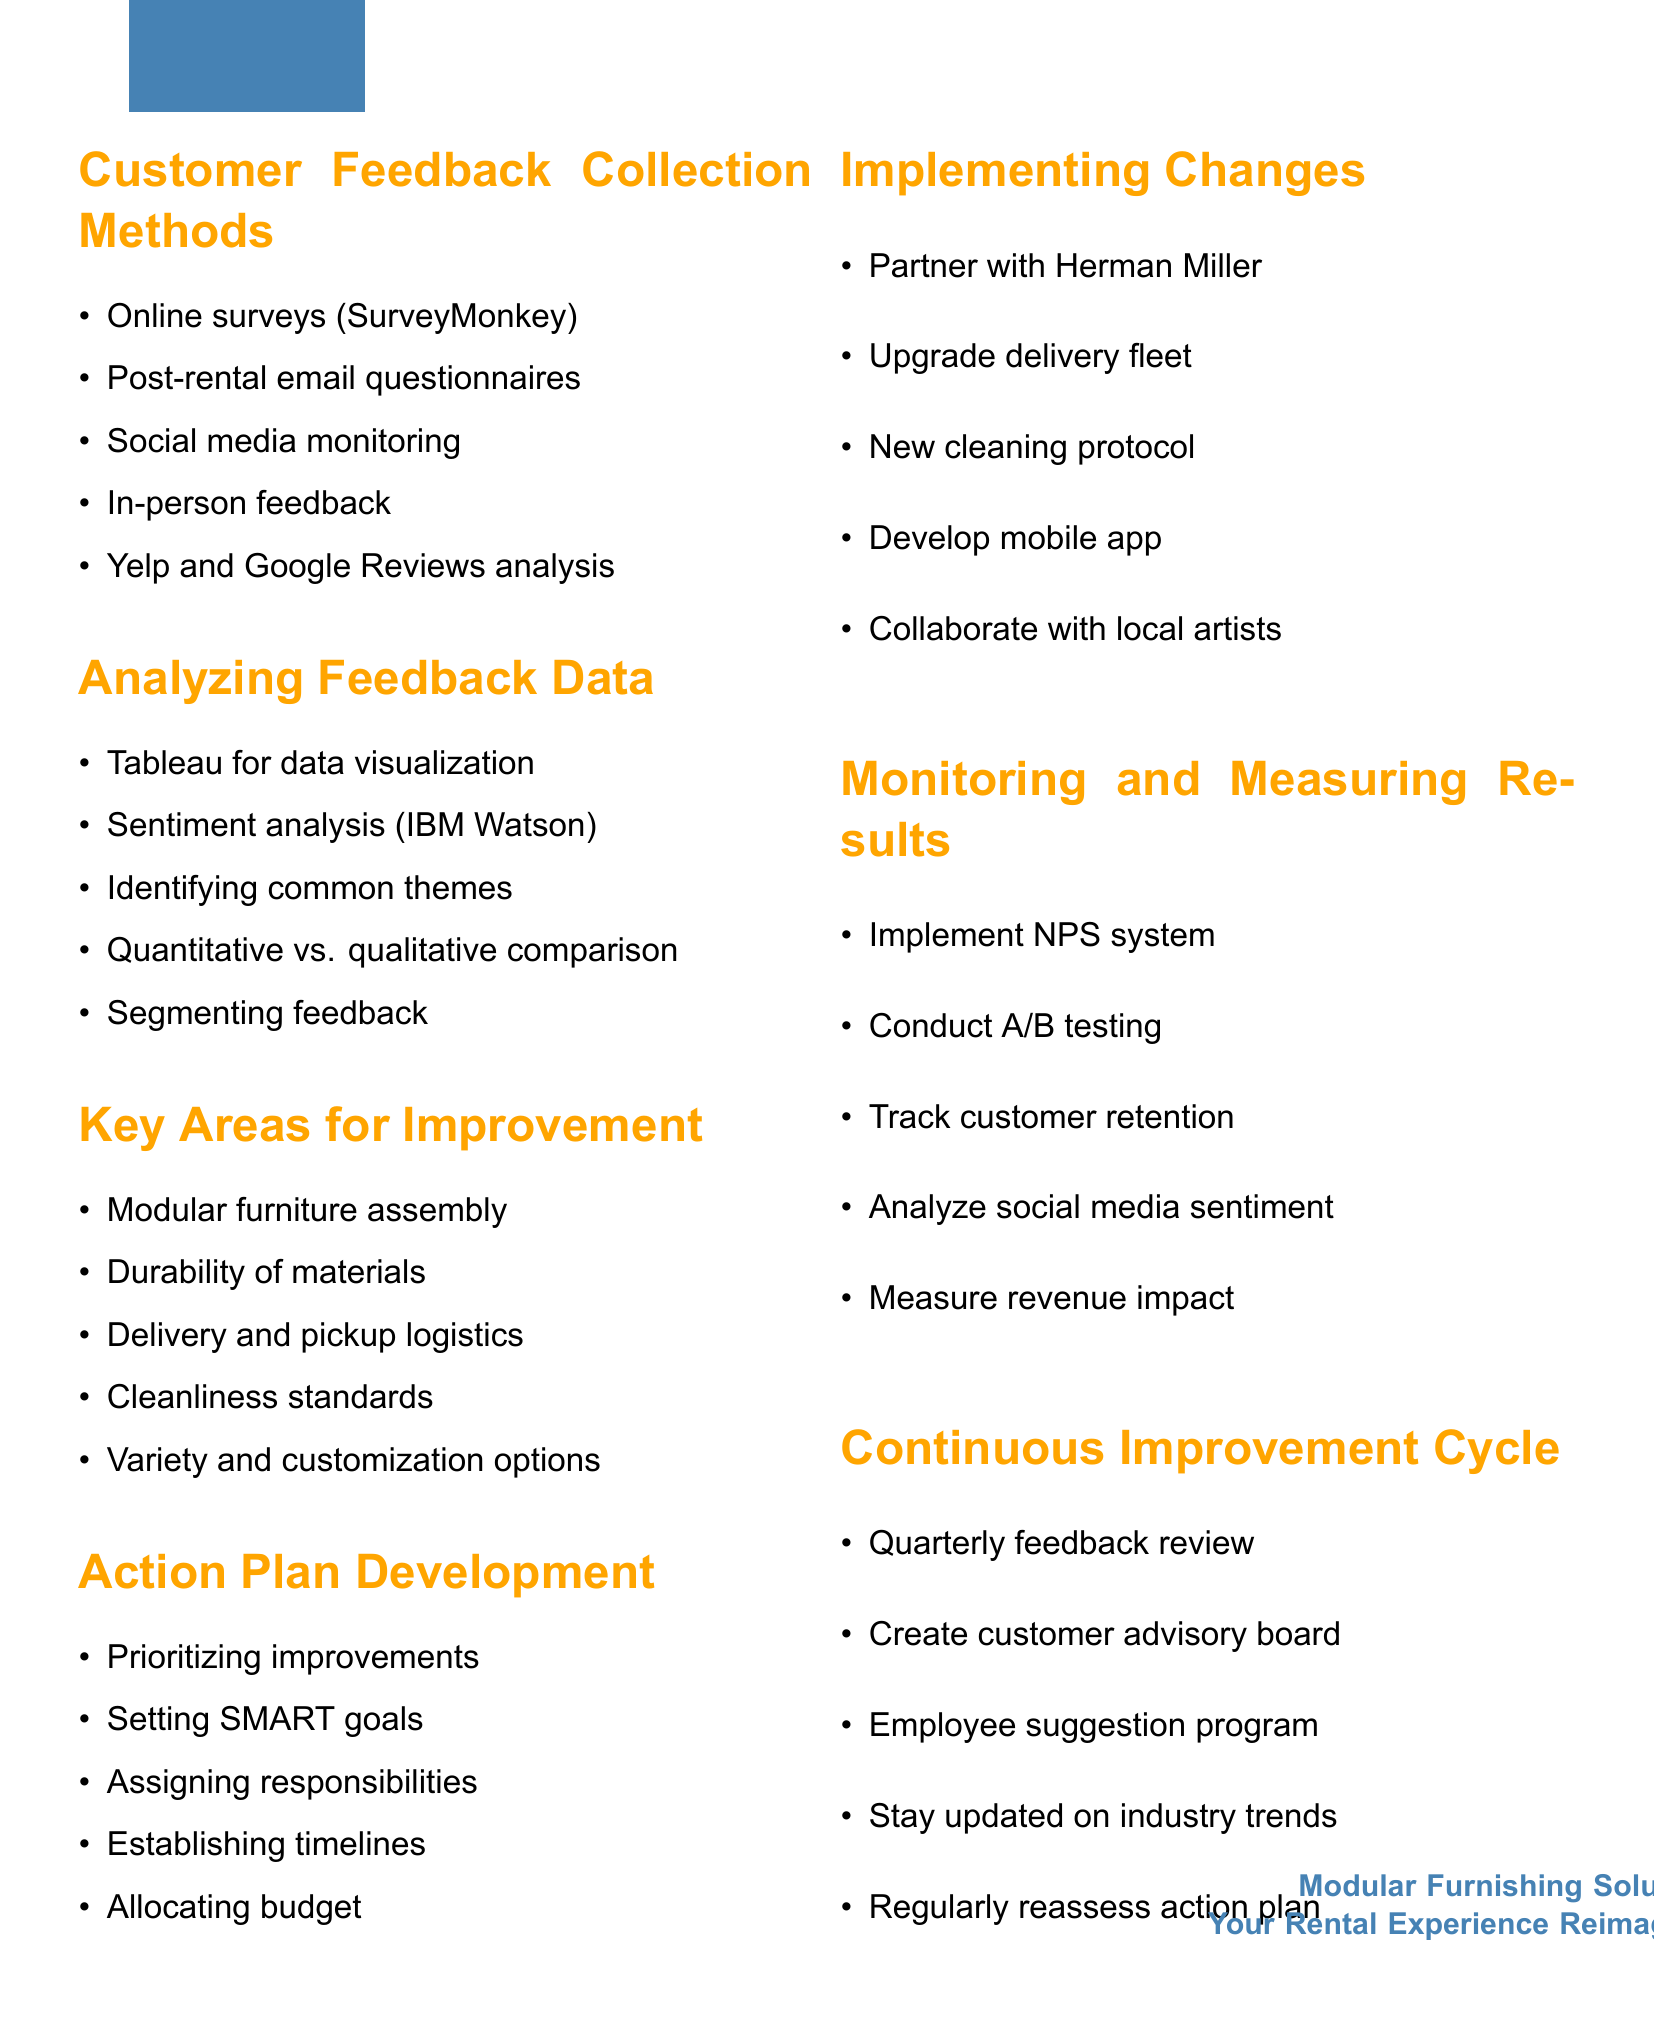What is the first method for collecting customer feedback? The first method listed under customer feedback collection is "Online surveys using SurveyMonkey."
Answer: Online surveys using SurveyMonkey Which tool is recommended for data visualization? The document suggests using "Tableau for data visualization."
Answer: Tableau What is one key area for improvement related to furniture? The document highlights "Durability of materials" as a key area for improvement.
Answer: Durability of materials What does NPS stand for in the monitoring section? NPS stands for "Net Promoter Score," which is mentioned for measuring results.
Answer: Net Promoter Score How often should feedback be reviewed according to the continuous improvement cycle? The document states that feedback should be reviewed "quarterly" as part of the continuous improvement process.
Answer: Quarterly Who is suggested to be partnered with for ergonomic modular designs? The document proposes "Herman Miller" for partnership to enhance ergonomic designs.
Answer: Herman Miller What should be established for ongoing customer input? The document recommends creating a "customer advisory board" for ongoing input.
Answer: Customer advisory board What type of testing is suggested for new versus old rental experiences? The suggestion in the document is to conduct "A/B testing" to compare experiences.
Answer: A/B testing What is a focus of the action plan development? The action plan development emphasizes "Setting SMART goals" for each improvement area.
Answer: Setting SMART goals 